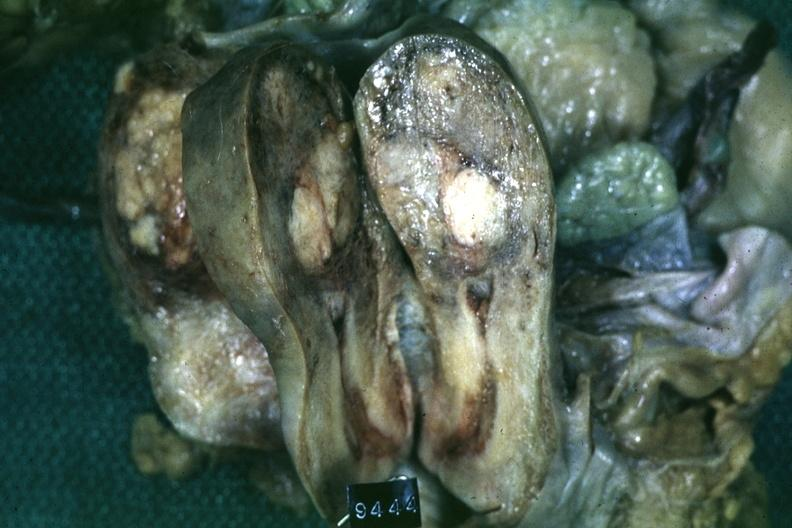what is present?
Answer the question using a single word or phrase. Leiomyoma 